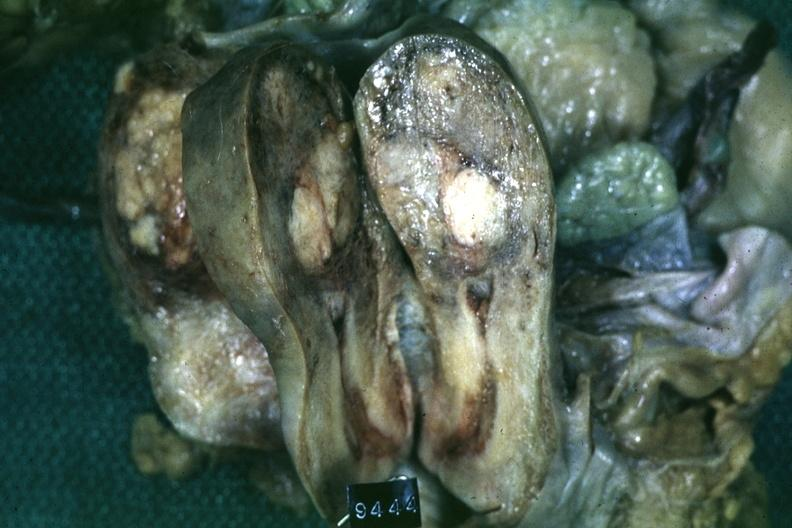what is present?
Answer the question using a single word or phrase. Leiomyoma 